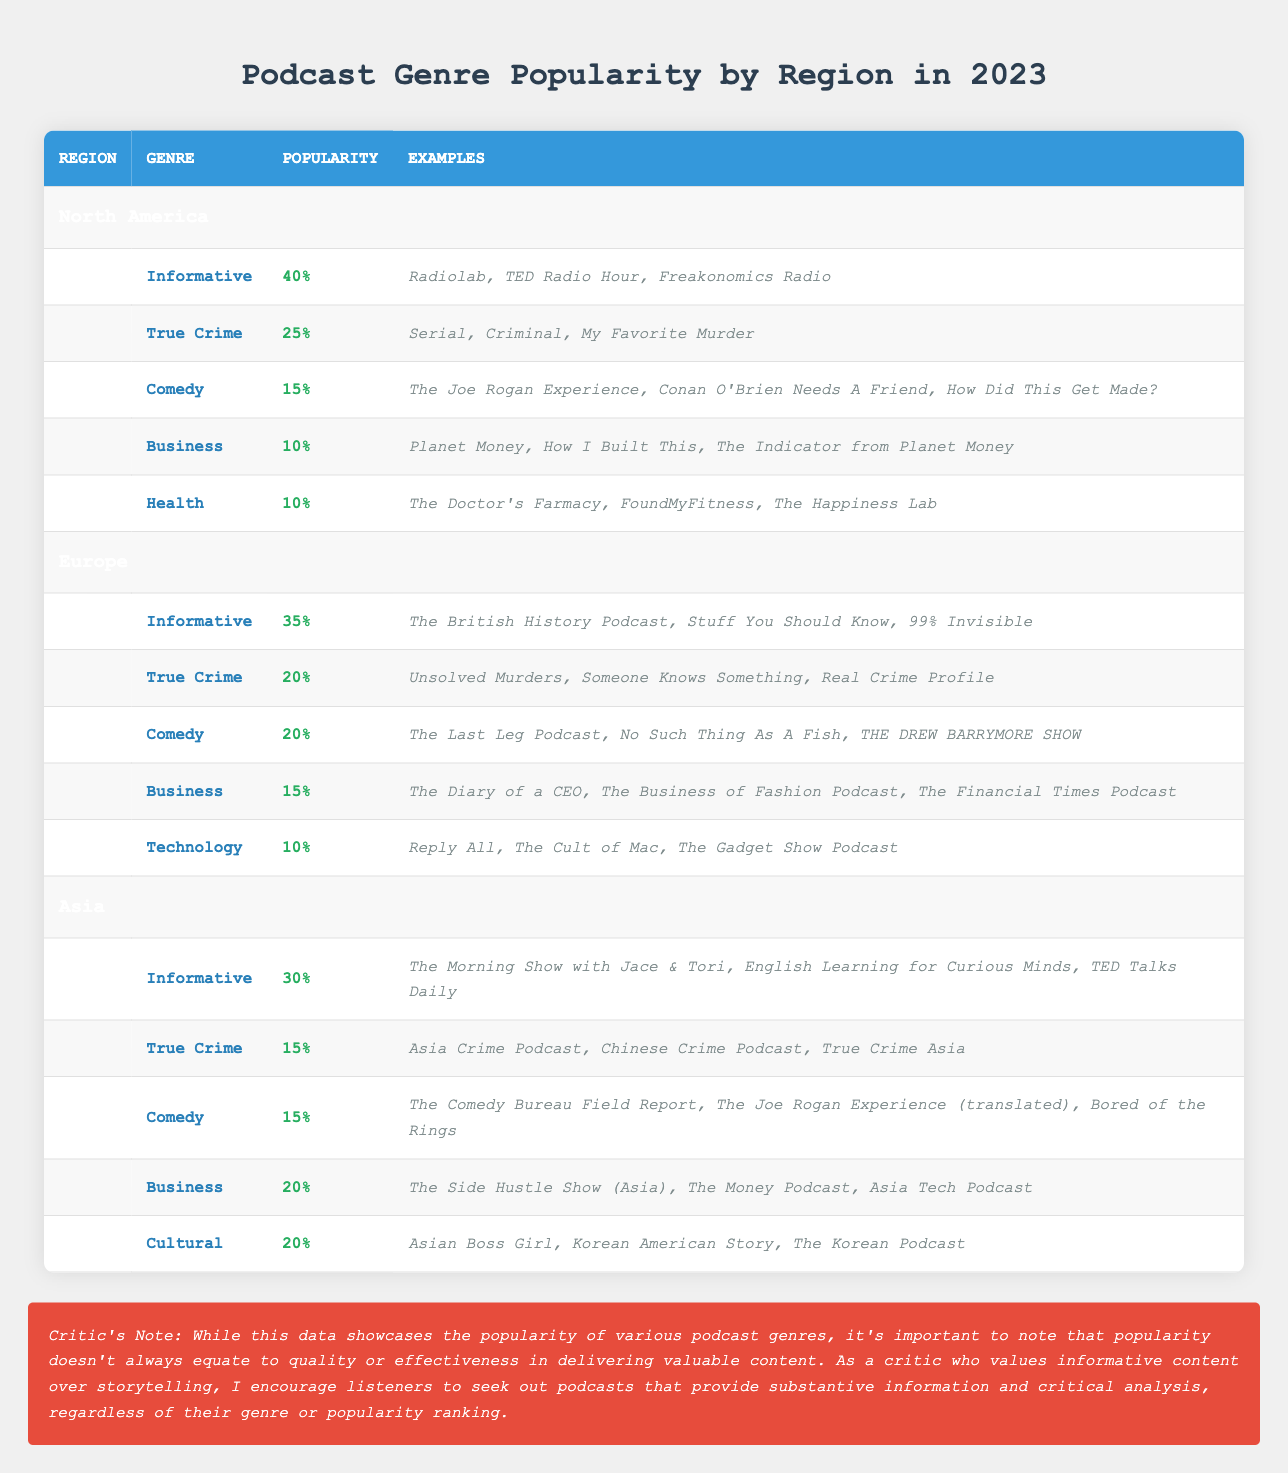What is the most popular podcast genre in North America? In the North America section of the table, the genre with the highest popularity percentage is Informative, which is listed as having a popularity of 40%.
Answer: Informative Which podcast genre has the same popularity in Europe and Asia? In the Europe and Asia sections, both have Comedy as a genre with a popularity of 15%. This indicates that both regions value Comedy podcasts equally in terms of popularity.
Answer: Comedy What is the combined percentage of the Business and Health genres in North America? To find the combined percentage, we add the popularity of the Business genre (10%) and the Health genre (10%). So, 10% + 10% = 20%.
Answer: 20% Is the popularity of True Crime in Europe higher than in Asia? True Crime has a popularity of 20% in Europe and 15% in Asia. Since 20% is greater than 15%, this statement is true.
Answer: Yes What is the average popularity percentage for the Informative genre across the three regions? The Informative genre has the following percentages: North America (40%), Europe (35%), and Asia (30%). First, sum these percentages: 40 + 35 + 30 = 105. Then, divide by the number of regions (3): 105 / 3 = 35.
Answer: 35 Which podcast genre has the lowest popularity in both North America and Europe? In North America, the Business and Health genres each have a popularity of 10%. In Europe, the Technology genre has the lowest popularity at 10% as well. Thus, the genres with the lowest popularity in North America are Business and Health, and for Europe, it is Technology.
Answer: Business, Health (North America); Technology (Europe) In which region is the True Crime genre most popular compared to others? In comparing the True Crime percentages across regions, it is 25% in North America, 20% in Europe, and 15% in Asia. Therefore, True Crime is most popular in North America.
Answer: North America Are there any podcast genres that share the same popularity percentage in all three regions? Upon reviewing the table, none of the genres hold the same popularity percentage across all three regions. Each genre varies in popularity per region.
Answer: No 